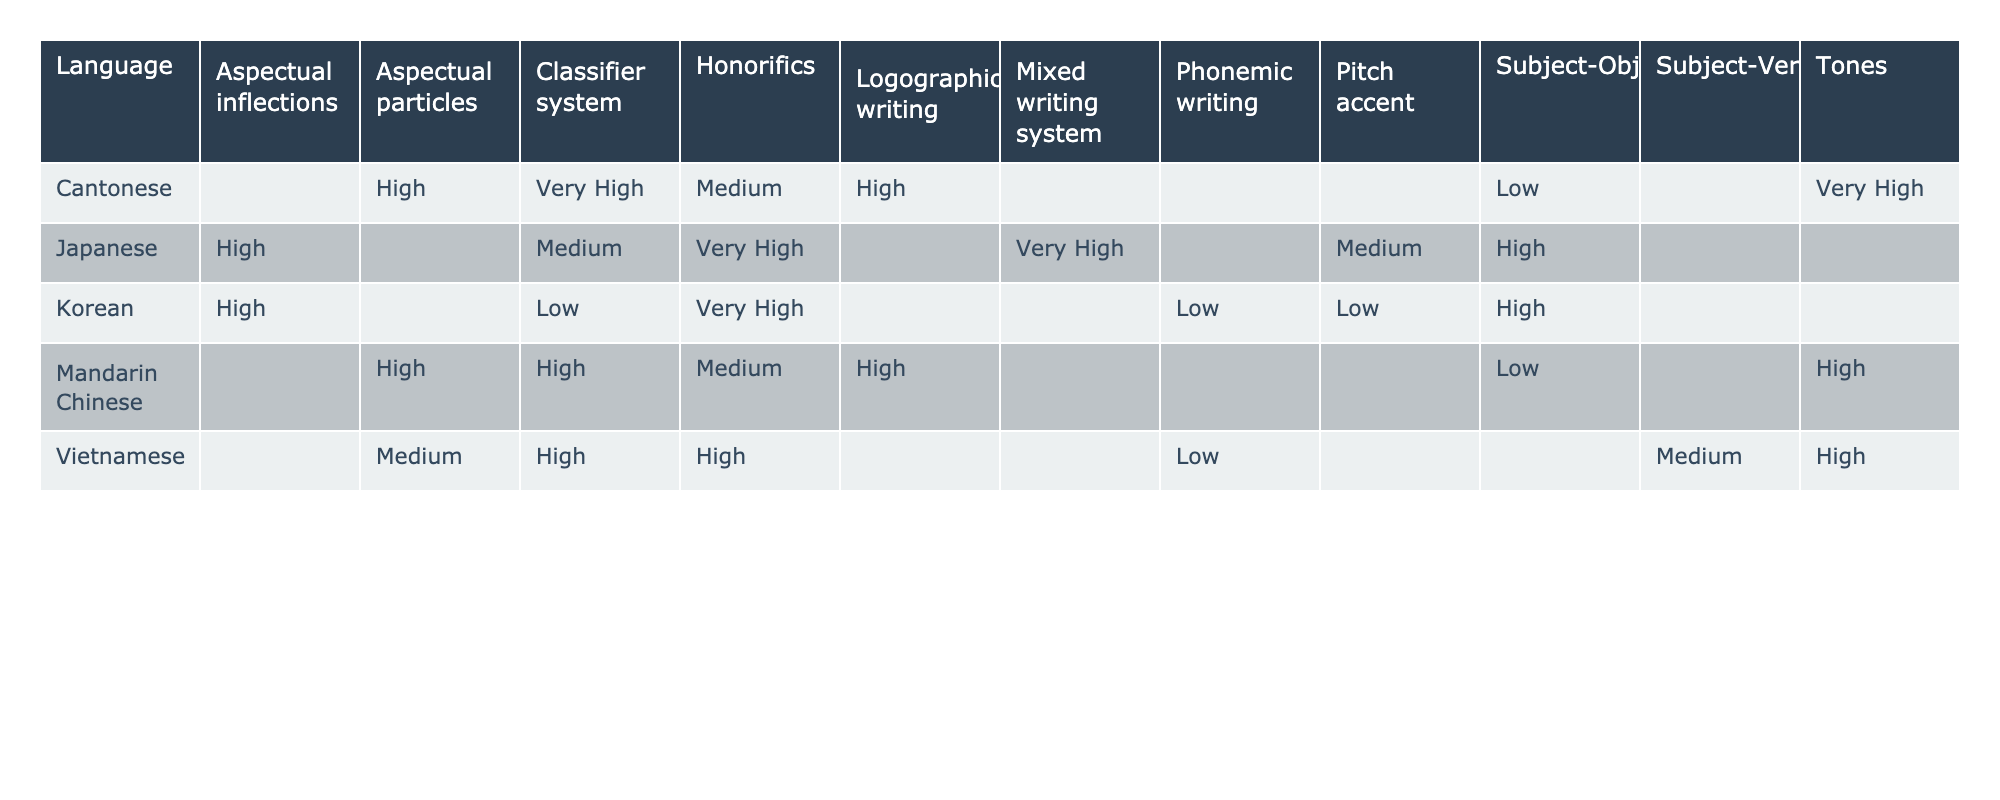What is the complexity level of tones in Cantonese? The table shows that Cantonese has a complexity level of "Very High" for the feature of tones, which is observed in the cell corresponding to the row Cantonese and the column Tones.
Answer: Very High Which language has the highest complexity for the classifier system? By inspecting the table, both Cantonese and Mandarin Chinese have a complexity level of "Very High" for the classifier system, but since they are equal, we consider both as the answer.
Answer: Cantonese and Mandarin Chinese Is Vietnamese the only language that uses Subject-Verb-Object syntax? Looking at the table, the Syntax feature shows that only Vietnamese has Subject-Verb-Object (SVO) while the others have Subject-Object-Verb (SOV) or other structures, confirming that it is the only one present here.
Answer: Yes Do all dialects have the same presence of honorifics? Checking the presence column for honorifics, all languages listed under this feature have "Yes," indicating that they all utilize honorifics.
Answer: Yes Which language has the lowest complexity for the pitch accent feature? Upon examining the Pitch accent feature in the table, Korean has a complexity level of "Low", which is the lowest compared to the other languages listed.
Answer: Korean What is the average complexity score for the Honorifics feature across all languages? The complexities for honorifics are listed as Medium, Medium, Very High, Very High, and High. Assigning values (Medium=3, High=4, Very High=5) gives us: (3 + 3 + 5 + 5 + 4) = 20; dividing by 5 languages results in an average of 20/5 = 4. Therefore, the average complexity for honorifics is High.
Answer: High Which language features a mixed writing system and what is its complexity? The table indicates that Japanese has a mixed writing system which comes with a complexity level of "Very High" according to the Orthographic category.
Answer: Very High How many languages present a classifier system with a complexity of High or above? The table shows Mandarin Chinese, Cantonese, and Vietnamese have a classifier system of High or above levels (Mandarin=High, Cantonese=Very High, and Vietnamese=High). We count these three languages to provide the answer.
Answer: 3 What is the difference in complexity between subject-object-verb and subject-verb-object languages? From the table, the complexity levels for Subject-Object-Verb languages (Japanese and Korean are High) is 4 for each language whereas Subject-Verb-Object (Vietnamese) has a complexity of 3. The difference is therefore 4 - 3 = 1.
Answer: 1 